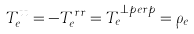Convert formula to latex. <formula><loc_0><loc_0><loc_500><loc_500>T _ { e } ^ { t t } = - T _ { e } ^ { r r } = T _ { e } ^ { \perp p e r p } = \rho _ { e }</formula> 